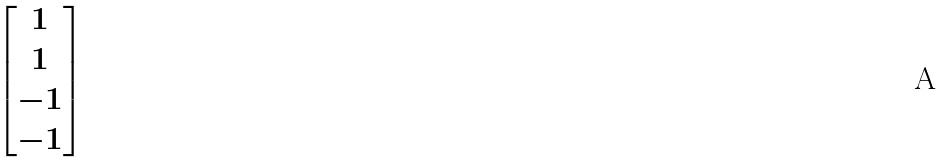Convert formula to latex. <formula><loc_0><loc_0><loc_500><loc_500>\begin{bmatrix} 1 \\ 1 \\ - 1 \\ - 1 \end{bmatrix}</formula> 